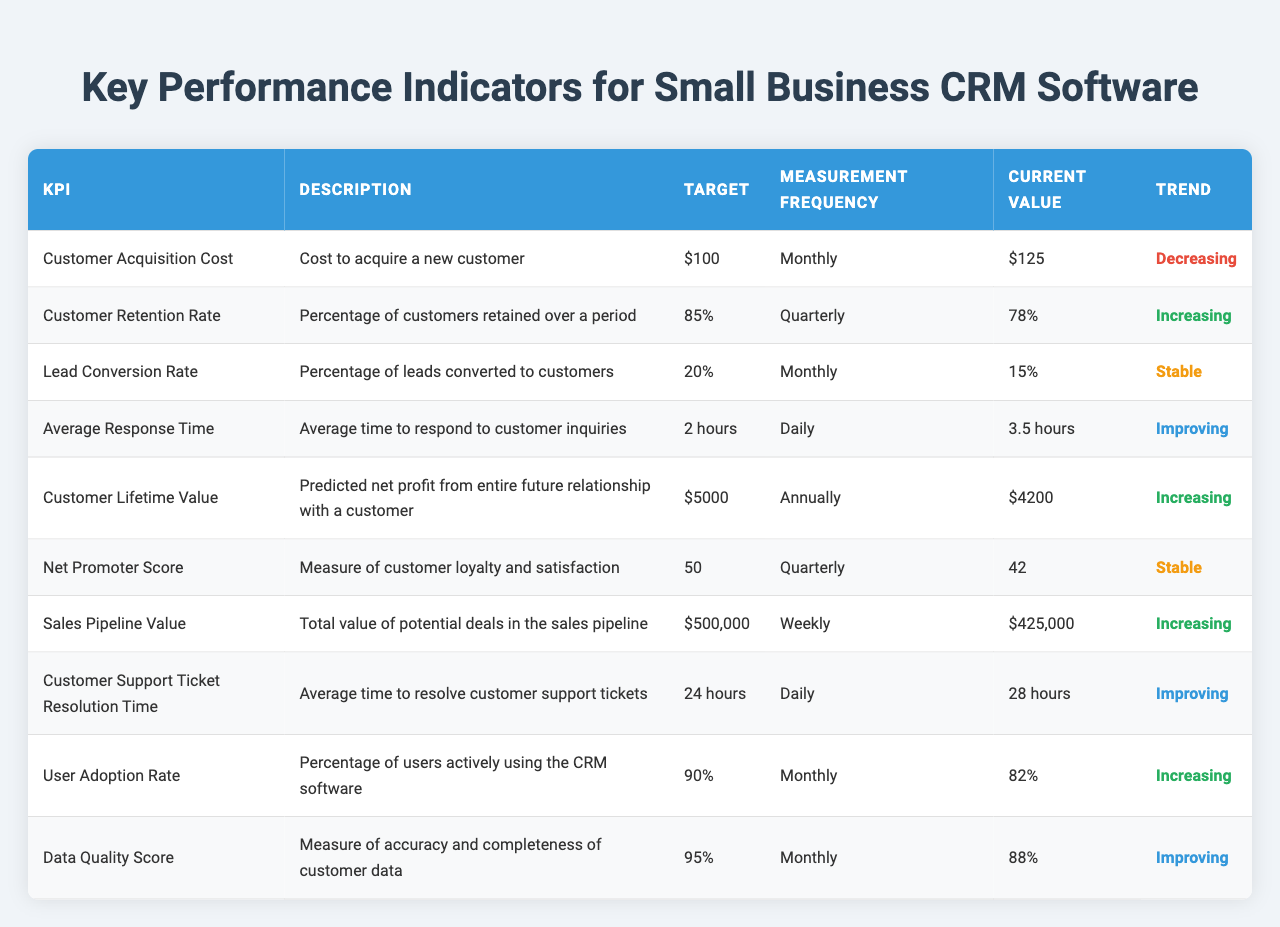What is the current value for Customer Acquisition Cost? The table shows the current value for "Customer Acquisition Cost" as "$125".
Answer: $125 What is the target for Customer Retention Rate? The target value for "Customer Retention Rate" is displayed as "85%".
Answer: 85% Is the Lead Conversion Rate currently above its target? The target for "Lead Conversion Rate" is "20%", but the current value is "15%", indicating it is below the target.
Answer: No What is the difference between the current value and the target for Customer Lifetime Value? The target for "Customer Lifetime Value" is "$5000" while the current value is "$4200". The difference is calculated as $5000 - $4200 = $800.
Answer: $800 How often is the Net Promoter Score measured? The table specifies that the measurement frequency for "Net Promoter Score" is "Quarterly".
Answer: Quarterly Which KPI has the most improving trend? The "Data Quality Score," "Average Response Time," and "Customer Support Ticket Resolution Time" all have the trend of "Improving", indicating significant progress.
Answer: Multiple KPIs What is the most recent value for User Adoption Rate and is it increasing towards its target? The "User Adoption Rate" has a current value of "82%" with a target of "90%". Although it is increasing, it has not yet reached the target.
Answer: Yes, but still below target Which KPIs are below target? The "Customer Acquisition Cost" ($125), "Customer Retention Rate" (78%), and "Lead Conversion Rate" (15%) are currently below their respective targets.
Answer: Three KPIs What is the trend for Average Response Time? The trend for "Average Response Time" is labeled as "Improving", despite currently being above the target of 2 hours.
Answer: Improving What is the total potential value of deals in the sales pipeline? The table shows the current value of the sales pipeline as "$425,000".
Answer: $425,000 Are there any KPIs with stable trends? "Net Promoter Score" and "Lead Conversion Rate" are highlighted as having a stable trend.
Answer: Yes 